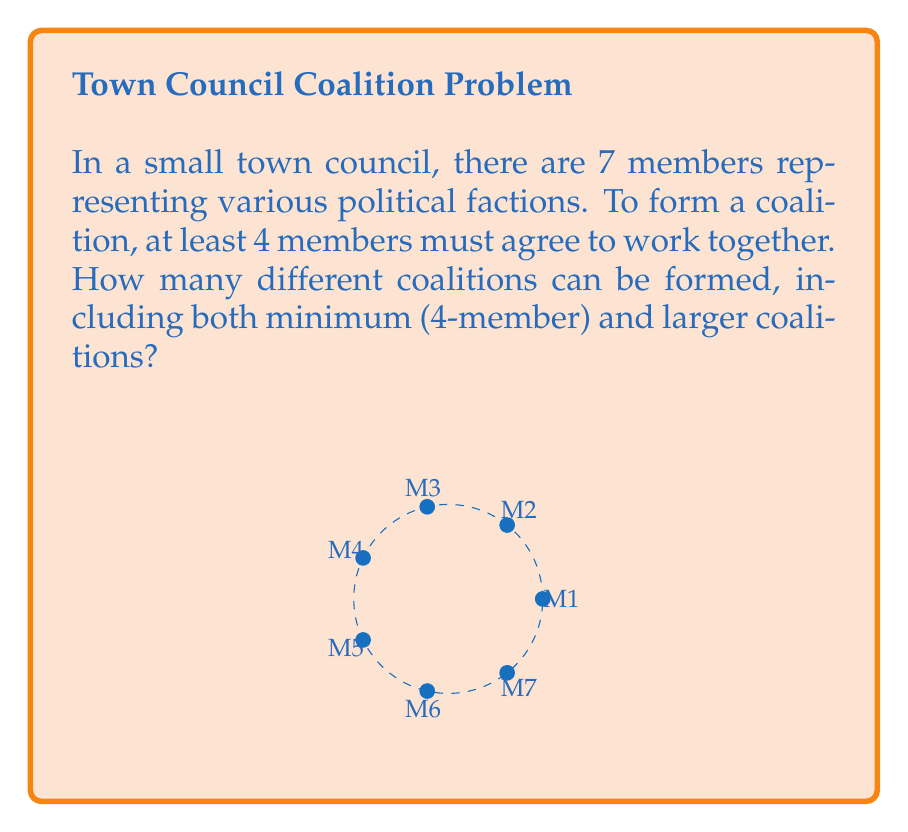Provide a solution to this math problem. To solve this problem, we need to count all possible combinations of 4, 5, 6, and 7 council members. We can use the combination formula for each case:

1) For 4-member coalitions: $${7 \choose 4} = \frac{7!}{4!(7-4)!} = \frac{7!}{4!3!} = 35$$

2) For 5-member coalitions: $${7 \choose 5} = \frac{7!}{5!(7-5)!} = \frac{7!}{5!2!} = 21$$

3) For 6-member coalitions: $${7 \choose 6} = \frac{7!}{6!(7-6)!} = \frac{7!}{6!1!} = 7$$

4) For 7-member coalition (all members): $${7 \choose 7} = 1$$

To get the total number of possible coalitions, we sum all these combinations:

$$35 + 21 + 7 + 1 = 64$$

Alternatively, we could have used the formula for the sum of combinations:

$$\sum_{k=4}^7 {7 \choose k} = 2^7 - {7 \choose 0} - {7 \choose 1} - {7 \choose 2} - {7 \choose 3} = 128 - 1 - 7 - 21 - 35 = 64$$

This approach counts all subsets of size 4 or larger, which is equivalent to subtracting the number of subsets of size 0, 1, 2, and 3 from the total number of subsets ($$2^7$$).
Answer: 64 coalitions 